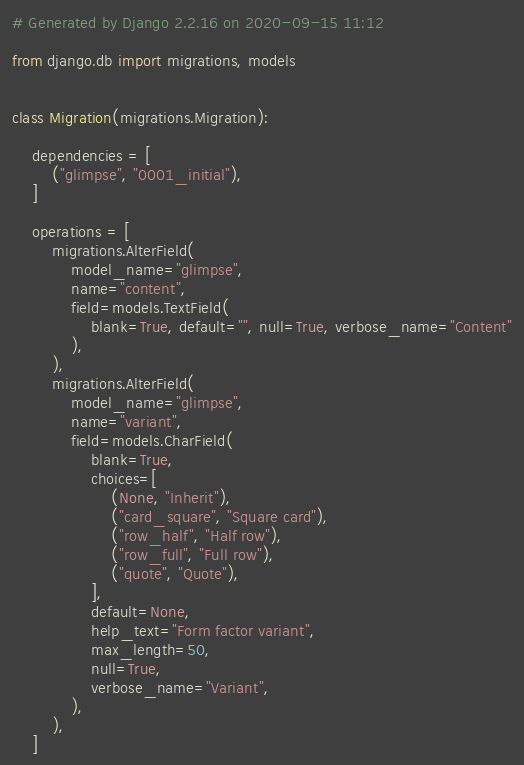<code> <loc_0><loc_0><loc_500><loc_500><_Python_># Generated by Django 2.2.16 on 2020-09-15 11:12

from django.db import migrations, models


class Migration(migrations.Migration):

    dependencies = [
        ("glimpse", "0001_initial"),
    ]

    operations = [
        migrations.AlterField(
            model_name="glimpse",
            name="content",
            field=models.TextField(
                blank=True, default="", null=True, verbose_name="Content"
            ),
        ),
        migrations.AlterField(
            model_name="glimpse",
            name="variant",
            field=models.CharField(
                blank=True,
                choices=[
                    (None, "Inherit"),
                    ("card_square", "Square card"),
                    ("row_half", "Half row"),
                    ("row_full", "Full row"),
                    ("quote", "Quote"),
                ],
                default=None,
                help_text="Form factor variant",
                max_length=50,
                null=True,
                verbose_name="Variant",
            ),
        ),
    ]
</code> 